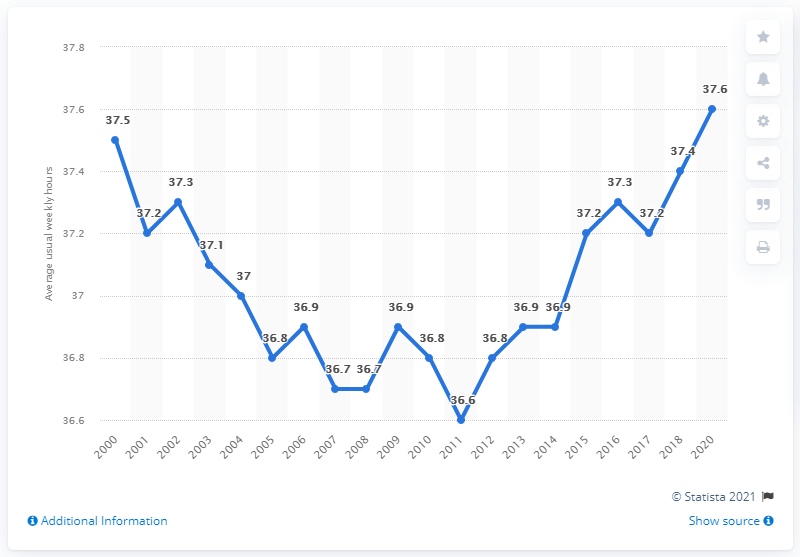Indicate a few pertinent items in this graphic. The mode is approximately 36.8. In 2019, the average number of weekly hours worked on the main job in Luxembourg was 37.6 hours. In 2000, the average weekly working hours for individuals in Luxembourg was 37.5 hours. 